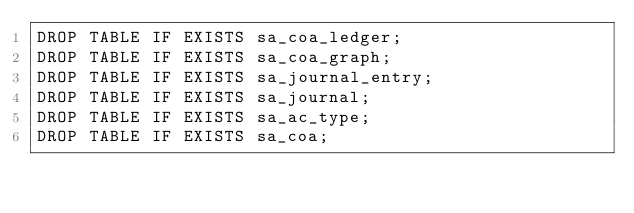Convert code to text. <code><loc_0><loc_0><loc_500><loc_500><_SQL_>DROP TABLE IF EXISTS sa_coa_ledger;
DROP TABLE IF EXISTS sa_coa_graph;
DROP TABLE IF EXISTS sa_journal_entry;
DROP TABLE IF EXISTS sa_journal;
DROP TABLE IF EXISTS sa_ac_type;
DROP TABLE IF EXISTS sa_coa;
</code> 